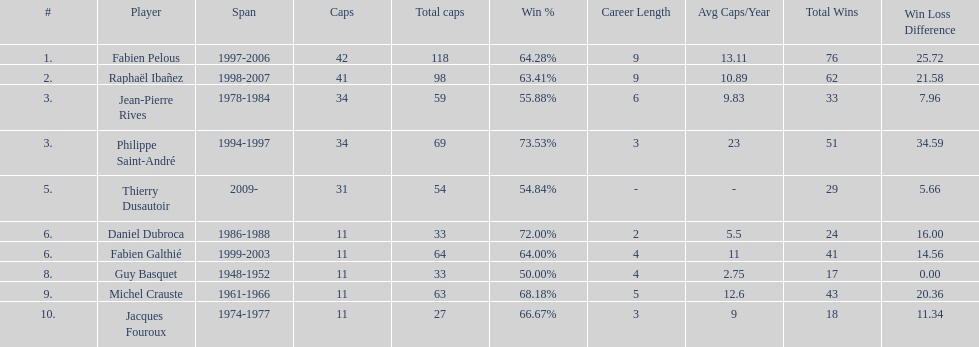How long did michel crauste serve as captain? 1961-1966. 